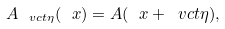Convert formula to latex. <formula><loc_0><loc_0><loc_500><loc_500>A _ { \ v c t \eta } ( \ x ) = A ( \ x + \ v c t \eta ) ,</formula> 